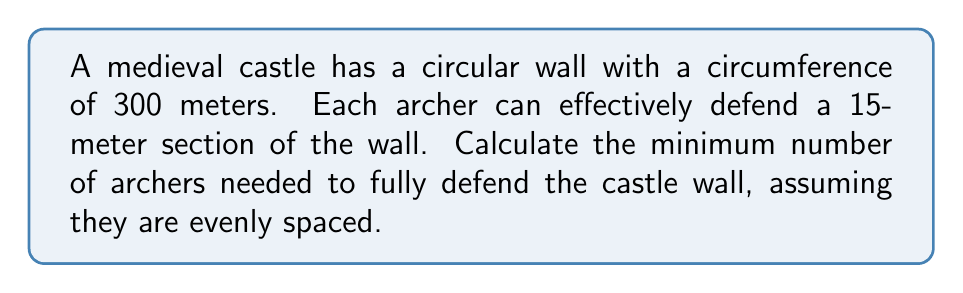Could you help me with this problem? To solve this problem, we need to determine how many 15-meter sections fit into the total circumference of the wall. This can be done by dividing the total circumference by the length each archer can defend.

Let's define our variables:
$C$ = Circumference of the wall
$L$ = Length each archer can defend
$N$ = Number of archers needed

We know that:
$C = 300$ meters
$L = 15$ meters

To find the number of archers, we use the formula:

$$N = \left\lceil\frac{C}{L}\right\rceil$$

Where $\lceil \rceil$ represents the ceiling function, which rounds up to the nearest integer. We use this because we need a whole number of archers, and any fractional part means we need one more archer to cover the remaining distance.

Plugging in our values:

$$N = \left\lceil\frac{300}{15}\right\rceil$$

$$N = \left\lceil20\right\rceil = 20$$

Therefore, we need 20 archers to fully defend the castle wall.

This solution ensures that:
1. The entire wall is covered (300 meters / 15 meters per archer = 20 archers)
2. We have a whole number of archers (we can't have a fractional archer)
3. The archers are evenly spaced along the wall

From a historical perspective, this method of calculation would have been crucial for castle defenders to ensure adequate protection while efficiently using their available manpower.
Answer: 20 archers 